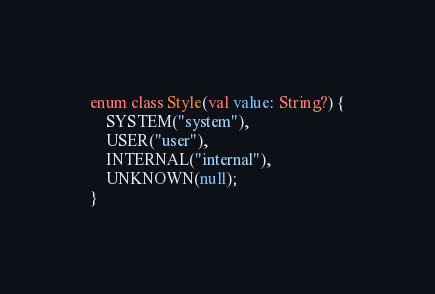<code> <loc_0><loc_0><loc_500><loc_500><_Kotlin_>enum class Style(val value: String?) {
    SYSTEM("system"),
    USER("user"),
    INTERNAL("internal"),
    UNKNOWN(null);
}</code> 